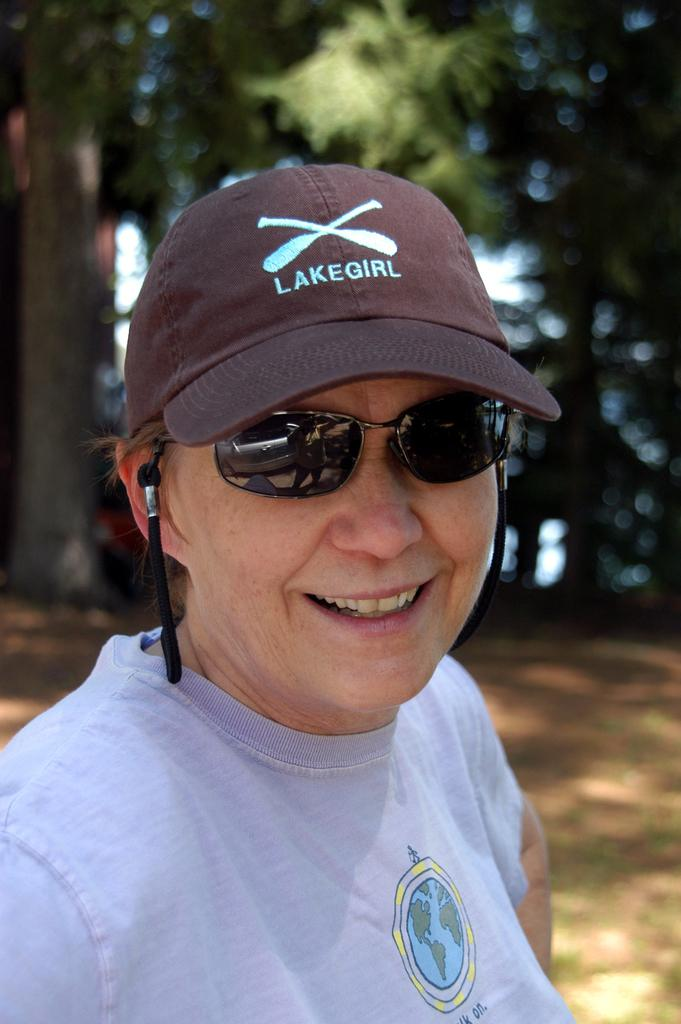Who or what is the main subject in the image? There is a person in the image. What protective gear is the person wearing? The person is wearing goggles and a cap. What can be seen in the background of the image? There are trees in the background of the image. What type of sponge is being used by the person in the image? There is no sponge present in the image; the person is wearing goggles and a cap. What achievement has the person in the image recently accomplished? The image does not provide any information about the person's achievements, so it cannot be determined from the image. 